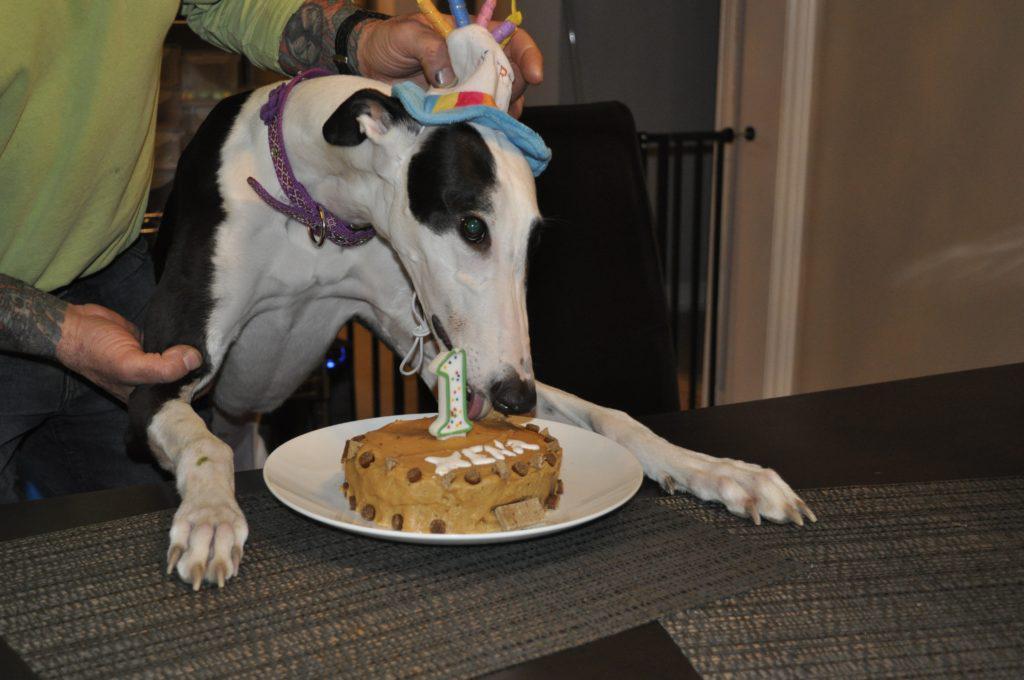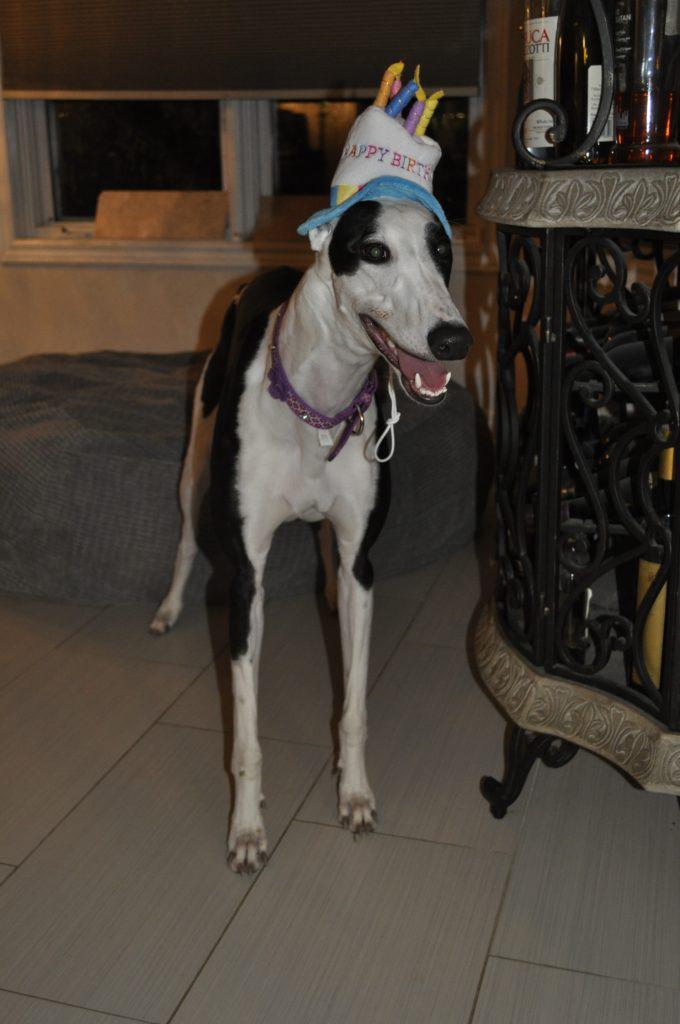The first image is the image on the left, the second image is the image on the right. Evaluate the accuracy of this statement regarding the images: "An image shows a human hand touching the head of a hound wearing a bandana.". Is it true? Answer yes or no. No. The first image is the image on the left, the second image is the image on the right. Considering the images on both sides, is "A person is with at least one dog in the grass in one of the pictures." valid? Answer yes or no. No. 